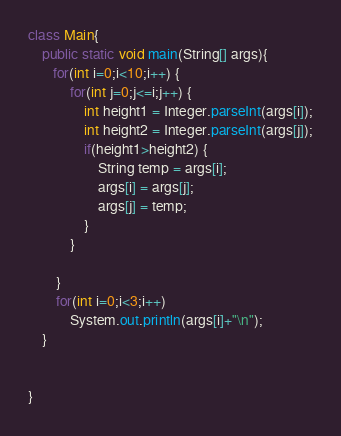Convert code to text. <code><loc_0><loc_0><loc_500><loc_500><_Java_>class Main{
    public static void main(String[] args){
       for(int i=0;i<10;i++) {
			for(int j=0;j<=i;j++) {
				int height1 = Integer.parseInt(args[i]);
				int height2 = Integer.parseInt(args[j]);
				if(height1>height2) {
					String temp = args[i];
					args[i] = args[j];
					args[j] = temp;
				}
			}
			
		}
		for(int i=0;i<3;i++)
			System.out.println(args[i]+"\n");
    }
	
    
}</code> 